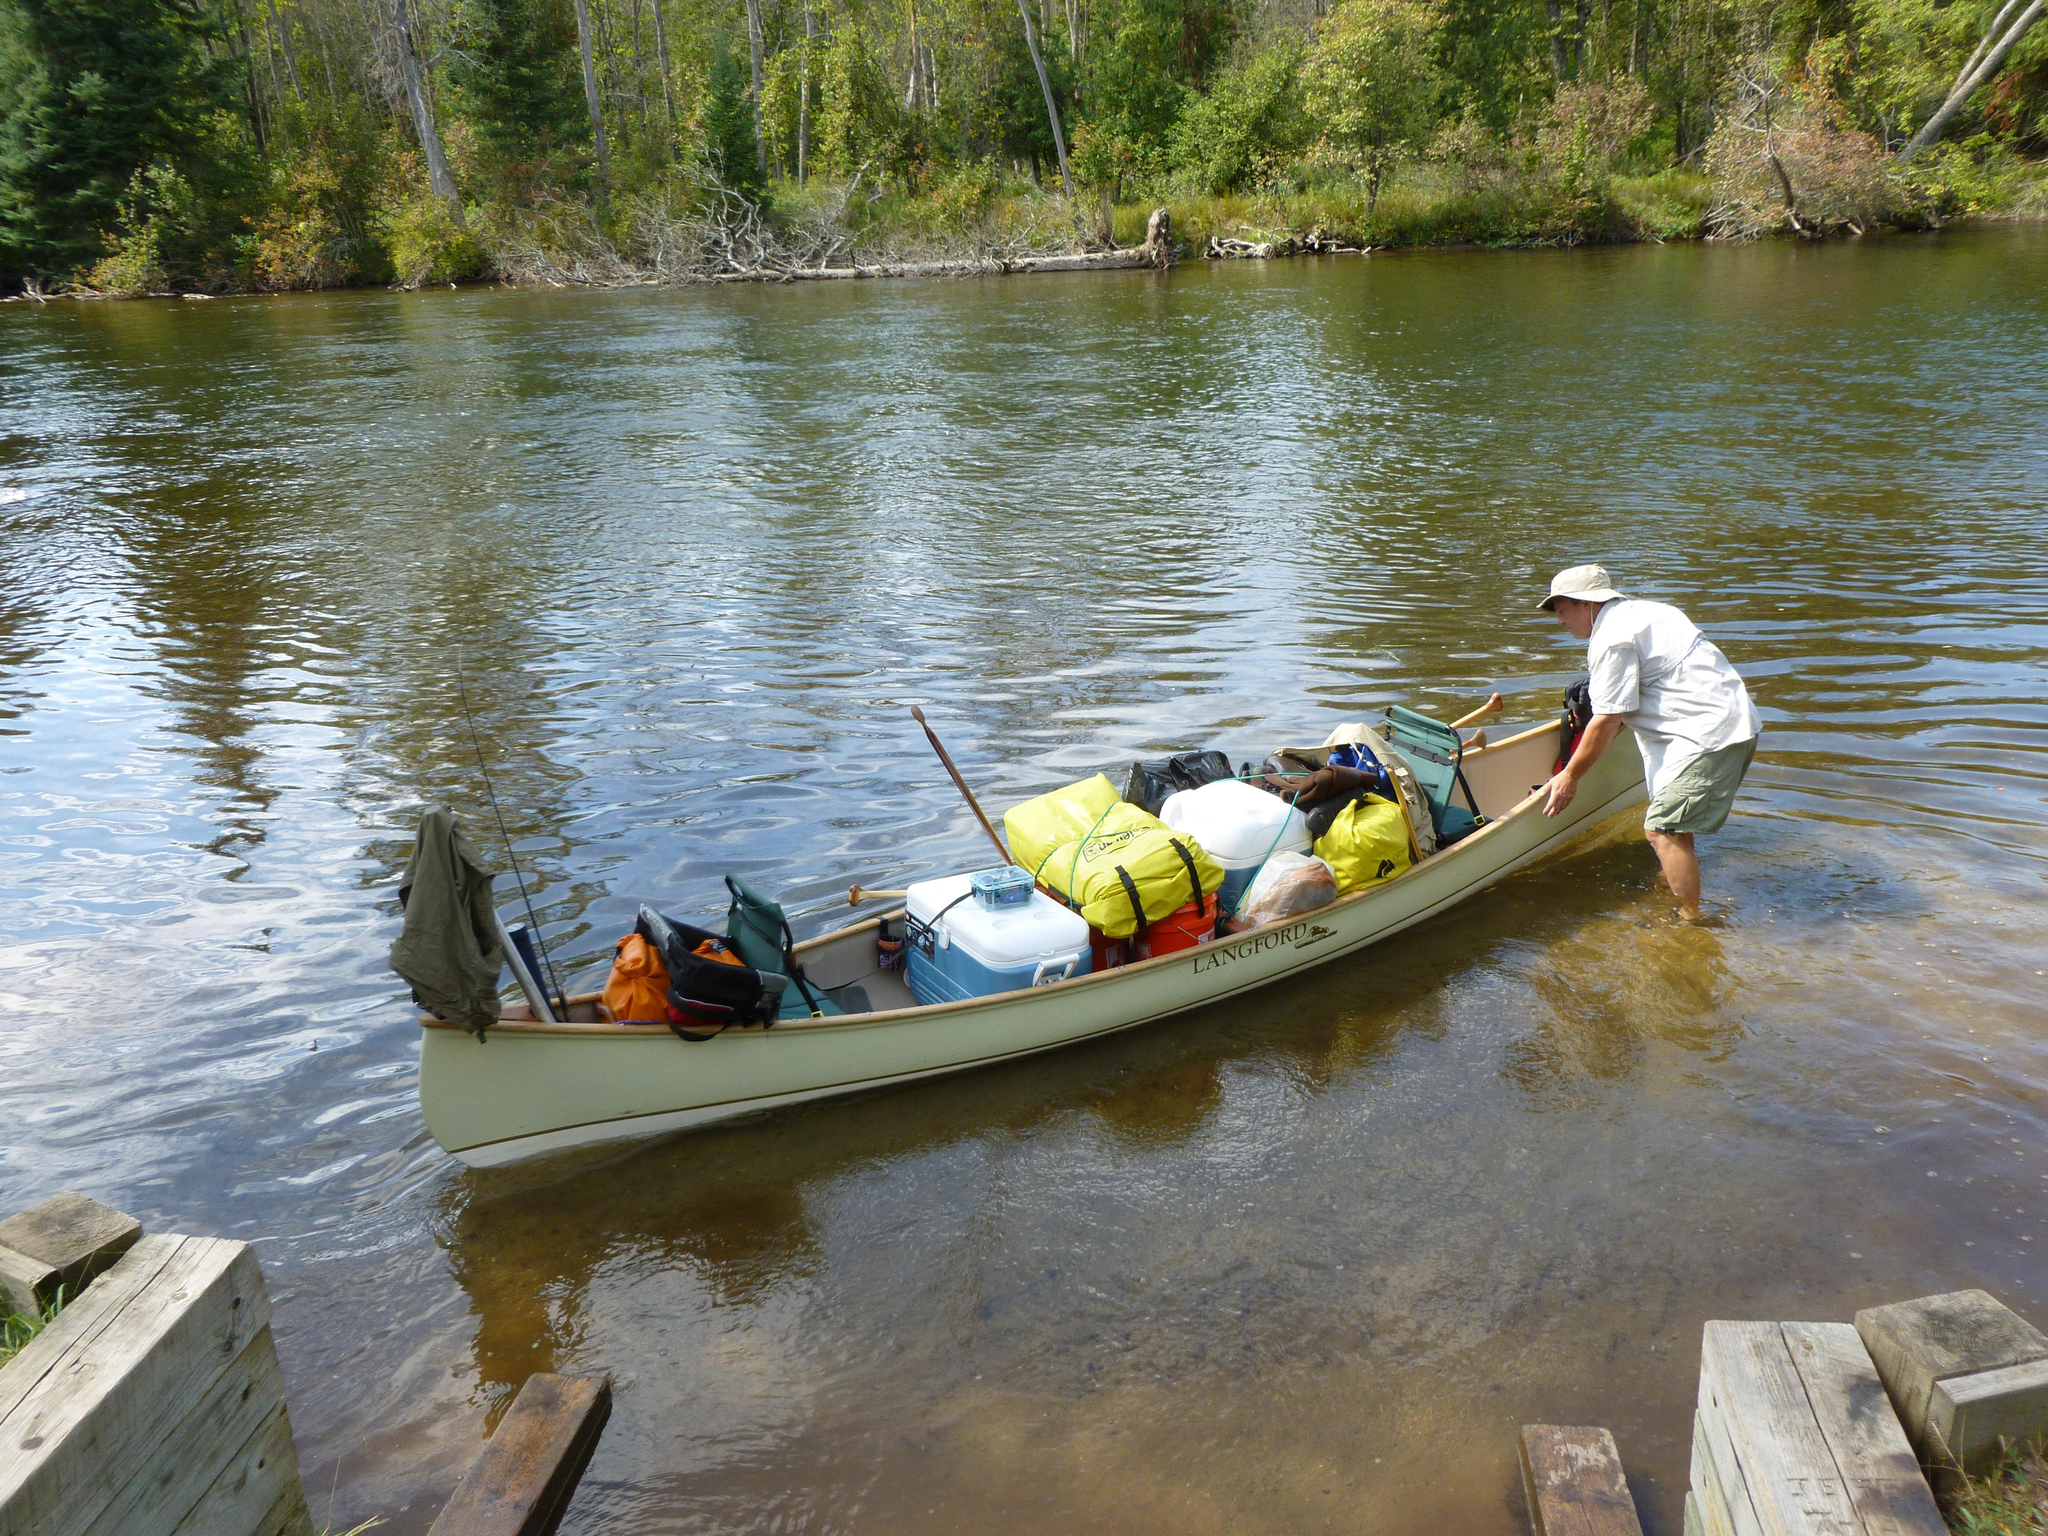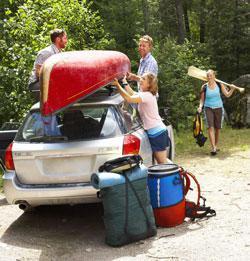The first image is the image on the left, the second image is the image on the right. For the images shown, is this caption "All boats are pictured in an area with water and full of gear, but no boats have a person inside." true? Answer yes or no. No. The first image is the image on the left, the second image is the image on the right. Assess this claim about the two images: "The right image includes one red canoe.". Correct or not? Answer yes or no. Yes. 